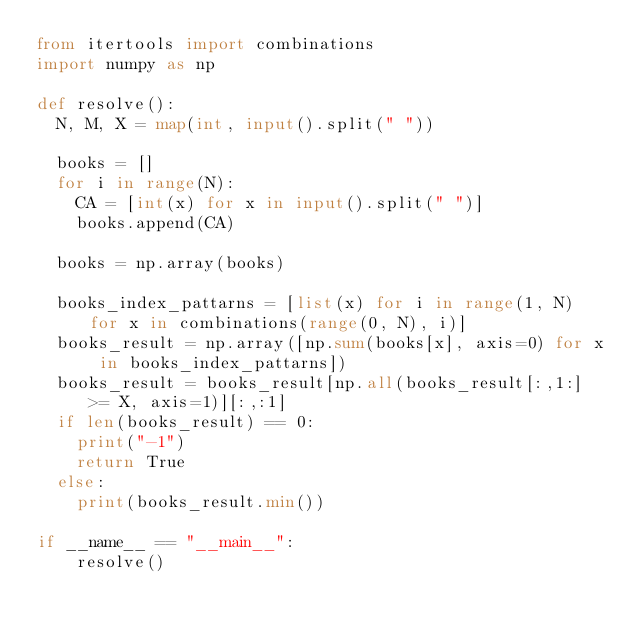<code> <loc_0><loc_0><loc_500><loc_500><_Python_>from itertools import combinations
import numpy as np

def resolve():
  N, M, X = map(int, input().split(" "))

  books = []
  for i in range(N):
    CA = [int(x) for x in input().split(" ")]
    books.append(CA)

  books = np.array(books)

  books_index_pattarns = [list(x) for i in range(1, N) for x in combinations(range(0, N), i)]
  books_result = np.array([np.sum(books[x], axis=0) for x in books_index_pattarns])
  books_result = books_result[np.all(books_result[:,1:] >= X, axis=1)][:,:1]
  if len(books_result) == 0:
    print("-1")
    return True
  else:
    print(books_result.min())

if __name__ == "__main__":
    resolve()</code> 